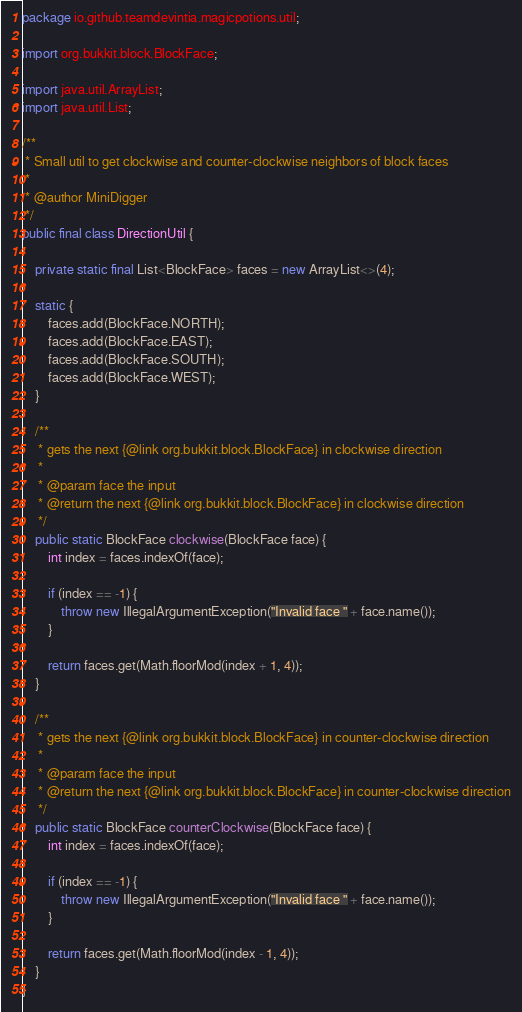Convert code to text. <code><loc_0><loc_0><loc_500><loc_500><_Java_>package io.github.teamdevintia.magicpotions.util;

import org.bukkit.block.BlockFace;

import java.util.ArrayList;
import java.util.List;

/**
 * Small util to get clockwise and counter-clockwise neighbors of block faces
 *
 * @author MiniDigger
 */
public final class DirectionUtil {

    private static final List<BlockFace> faces = new ArrayList<>(4);

    static {
        faces.add(BlockFace.NORTH);
        faces.add(BlockFace.EAST);
        faces.add(BlockFace.SOUTH);
        faces.add(BlockFace.WEST);
    }

    /**
     * gets the next {@link org.bukkit.block.BlockFace} in clockwise direction
     *
     * @param face the input
     * @return the next {@link org.bukkit.block.BlockFace} in clockwise direction
     */
    public static BlockFace clockwise(BlockFace face) {
        int index = faces.indexOf(face);

        if (index == -1) {
            throw new IllegalArgumentException("Invalid face " + face.name());
        }

        return faces.get(Math.floorMod(index + 1, 4));
    }

    /**
     * gets the next {@link org.bukkit.block.BlockFace} in counter-clockwise direction
     *
     * @param face the input
     * @return the next {@link org.bukkit.block.BlockFace} in counter-clockwise direction
     */
    public static BlockFace counterClockwise(BlockFace face) {
        int index = faces.indexOf(face);

        if (index == -1) {
            throw new IllegalArgumentException("Invalid face " + face.name());
        }

        return faces.get(Math.floorMod(index - 1, 4));
    }
}
</code> 